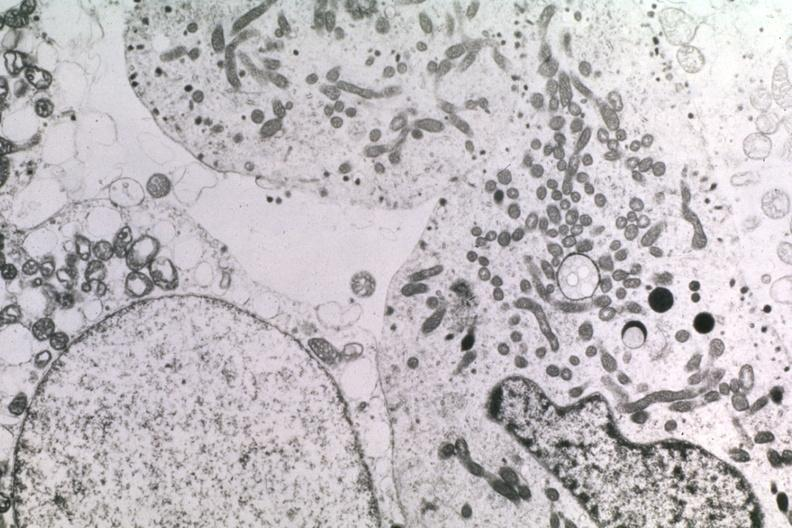s endocrine present?
Answer the question using a single word or phrase. Yes 